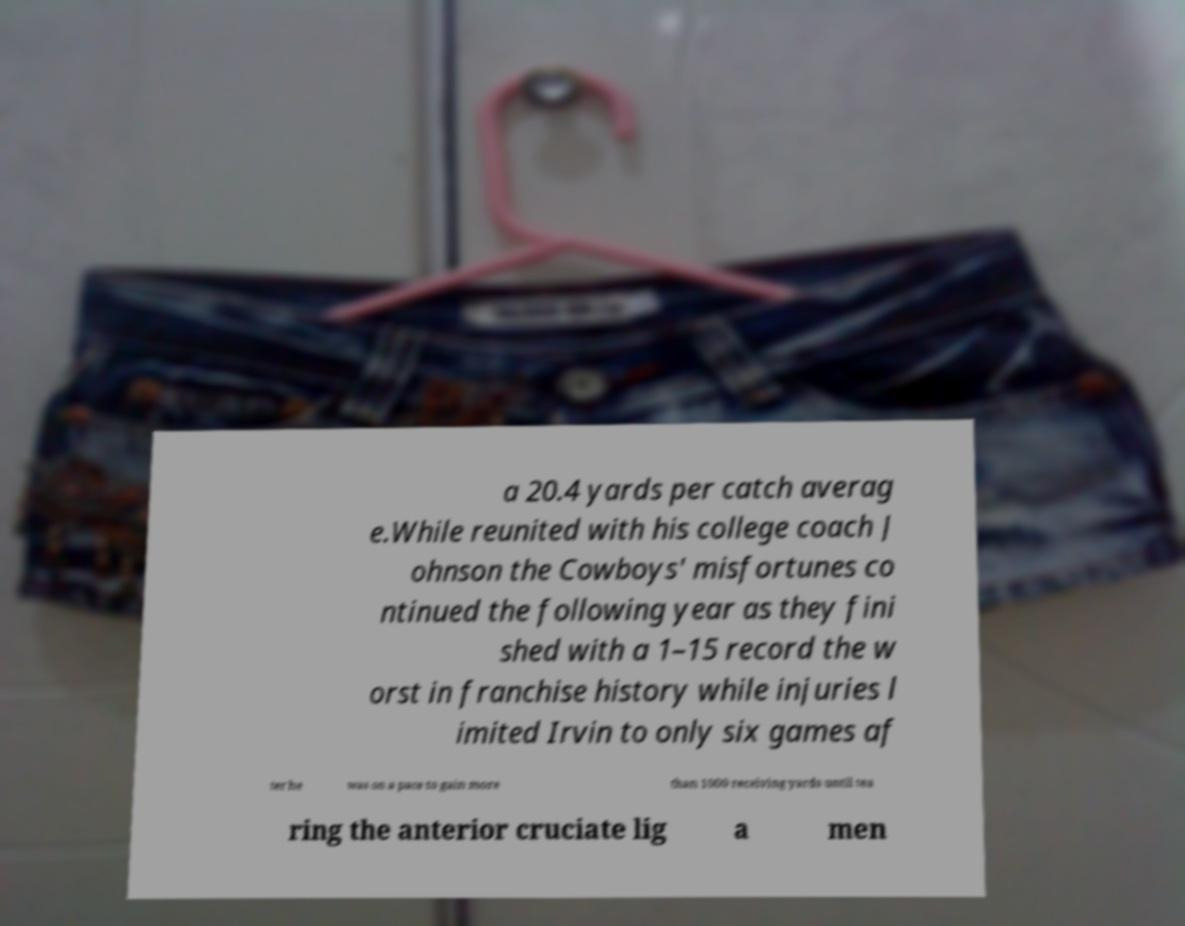There's text embedded in this image that I need extracted. Can you transcribe it verbatim? a 20.4 yards per catch averag e.While reunited with his college coach J ohnson the Cowboys' misfortunes co ntinued the following year as they fini shed with a 1–15 record the w orst in franchise history while injuries l imited Irvin to only six games af ter he was on a pace to gain more than 1000 receiving yards until tea ring the anterior cruciate lig a men 